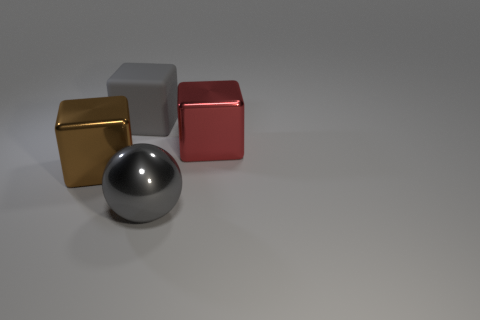Subtract all metallic blocks. How many blocks are left? 1 Add 4 gray cubes. How many objects exist? 8 Subtract all gray blocks. How many blocks are left? 2 Subtract all blocks. How many objects are left? 1 Subtract all big gray rubber things. Subtract all gray spheres. How many objects are left? 2 Add 2 matte objects. How many matte objects are left? 3 Add 1 big brown metal objects. How many big brown metal objects exist? 2 Subtract 1 gray cubes. How many objects are left? 3 Subtract all red spheres. Subtract all blue cubes. How many spheres are left? 1 Subtract all cyan cylinders. How many brown blocks are left? 1 